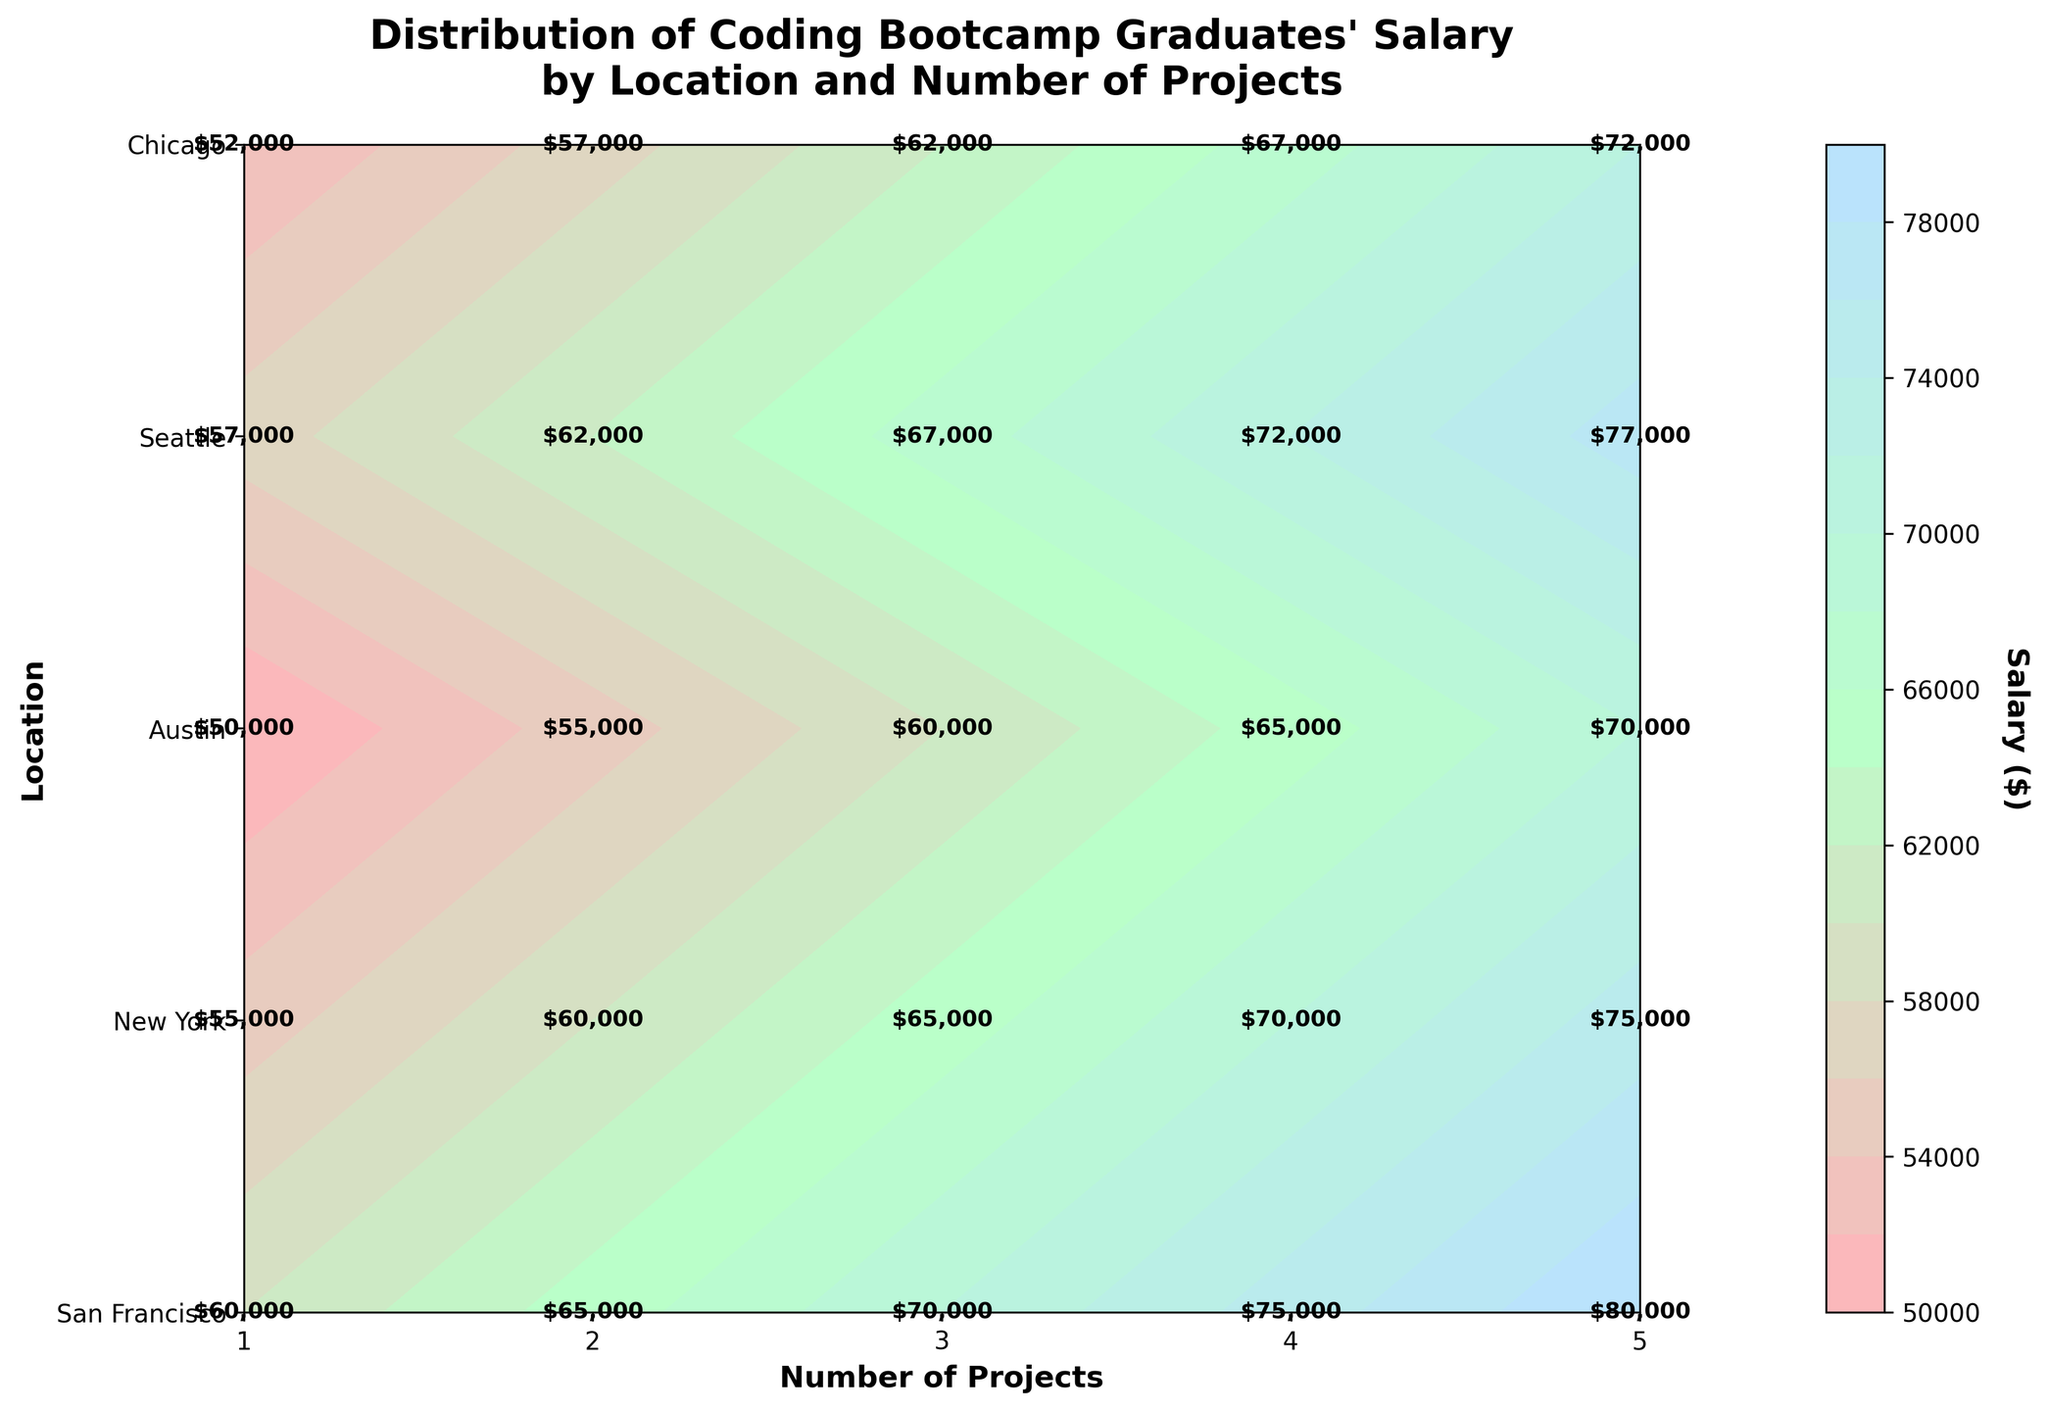What's the title of the figure? The title is usually located at the top of the figure and summarizes the key information being presented. From the visual, the title reads: "Distribution of Coding Bootcamp Graduates' Salary by Location and Number of Projects".
Answer: Distribution of Coding Bootcamp Graduates' Salary by Location and Number of Projects Which location has the highest salary at 5 projects completed? Look at the contour plot's y-axis labels for different locations and find the maximum value in the color scale for 5 projects completed. From the visual, the highest salary for 5 projects is in San Francisco, noted as $80,000.
Answer: San Francisco How many levels are in the contour plot? Count the distinct contour levels or refer to the color bar on the right for the number of salary divisions. The figure mentions that there are 15 levels.
Answer: 15 What is the salary difference between 1 project completed in San Francisco and 1 project completed in Austin? Identify the salary for 1 project in both locations; San Francisco shows $60,000, and Austin shows $50,000. Subtract Austin's from San Francisco's salary: $60,000 - $50,000.
Answer: $10,000 What is the average salary for 3 projects in all locations? To find the average, sum the salaries for 3 projects in San Francisco ($70,000), New York ($65,000), Austin ($60,000), Seattle ($67,000), and Chicago ($62,000), then divide by 5: (70,000 + 65,000 + 60,000 + 67,000 + 62,000) / 5.
Answer: $64,800 Which city shows consistent salary increases with the number of projects completed? Examine the salary increments across all project completions for each city. Each city's trend can be identified as either consistent increase or otherwise. From the visual, San Francisco shows consistent increases per project.
Answer: San Francisco Between New York and Seattle, which location has a higher salary for 2 projects completed? Compare the salaries from the contour plot or labels for 2 projects completed in New York and Seattle. New York shows $60,000, while Seattle shows $62,000.
Answer: Seattle For a graduate with 4 projects completed, what is the salary range among all locations? Identify the lowest and highest salaries for 4 projects completed. The lowest is in Austin ($65,000), and the highest is in San Francisco ($75,000). Thus, the range is $75,000 - $65,000.
Answer: $10,000 If a student plans to complete 5 projects, which two locations would you recommend for the highest and second highest salaries? Look at the contour levels or labels for 5 projects and identify the top two salaries. The highest is in San Francisco ($80,000) and the second highest in Seattle ($77,000).
Answer: San Francisco and Seattle What’s the position of the color bar in the figure, and what does it represent? The color bar is positioned on the right side of the figure. It represents the salary distribution (in dollars) associated with contour levels, with labels indicating specific salary values.
Answer: Right side, indicating salary distribution 